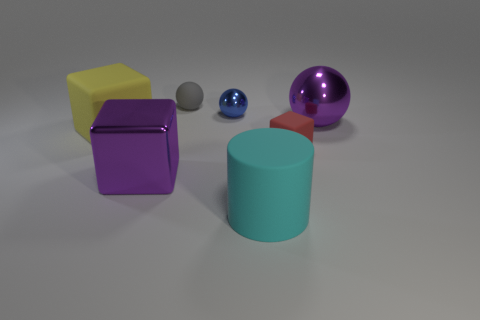Are there any big metal things of the same shape as the red rubber object?
Provide a succinct answer. Yes. What number of objects are big purple objects or cubes to the left of the tiny gray object?
Offer a terse response. 3. What number of other things are there of the same material as the gray object
Make the answer very short. 3. How many things are large purple shiny cubes or metallic spheres?
Provide a succinct answer. 3. Are there more rubber cylinders to the left of the big cyan thing than large blocks that are right of the large sphere?
Give a very brief answer. No. Is the color of the metal ball that is right of the large rubber cylinder the same as the shiny thing that is left of the blue metallic sphere?
Ensure brevity in your answer.  Yes. There is a metal object in front of the big metallic object right of the small ball that is behind the small metal ball; what size is it?
Give a very brief answer. Large. What color is the tiny rubber object that is the same shape as the tiny shiny thing?
Your response must be concise. Gray. Are there more cyan objects in front of the small blue ball than purple rubber things?
Your response must be concise. Yes. Is the shape of the large yellow thing the same as the small rubber object to the left of the large cyan cylinder?
Give a very brief answer. No. 